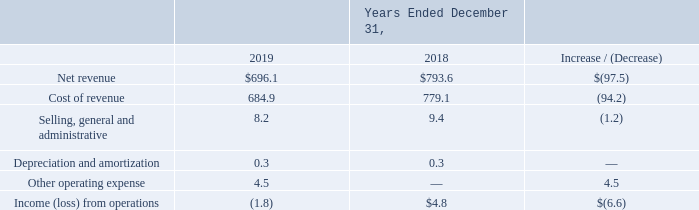Telecommunications Segment
Net revenue: Net revenue from our Telecommunications segment for the year ended December 31, 2019 decreased $97.5 million to $696.1 million from $793.6 million for the year ended December 31, 2018. The decrease can be attributed to changes in our customer mix, fluctuations in wholesale voice termination volumes and market pressures, which resulted in a decline in revenue contribution.
Cost of revenue: Cost of revenue from our Telecommunications segment for the year ended December 31, 2019 decreased $94.2 million to $684.9 million from $779.1 million for the year ended December 31, 2018. The decrease was directly correlated to the fluctuations in wholesale voice termination volumes, in addition to a slight reduction in margin mix attributed to market pressures on call termination rates.
Selling, general and administrative: Selling, general and administrative expenses from our Telecommunications segment for the year ended December 31, 2019 decreased $1.2 million to $8.2 million from $9.4 million for the year ended December 31, 2018. The decrease was primarily due to a decrease in compensation expense due to headcount decreases and reductions in bad debt expense.
Other operating expense: $4.5 million of other operating expense for the year ended December 31, 2019 was driven by impairment of goodwill as a result of declining performance at the segment.
What was the net revenue for the year ended December 31, 2019? $696.1 million. What was the selling, general and administrative expense for the year ended December 31, 2018? $8.2 million. What was the cost of revenue for the year ended December 31, 2019? $684.9 million. What was the percentage increase / (decrease) in the net revenue from 2018 to 2019?
Answer scale should be: percent. 696.1 / 793.6 - 1
Answer: -12.29. What was the average cost of revenue?
Answer scale should be: million. (684.9 + 779.1) / 2
Answer: 732. What is the percentage increase / (decrease) in the Depreciation and amortization from 2018 to 2019?
Answer scale should be: percent. 0.3 / 0.3 - 1
Answer: 0. 